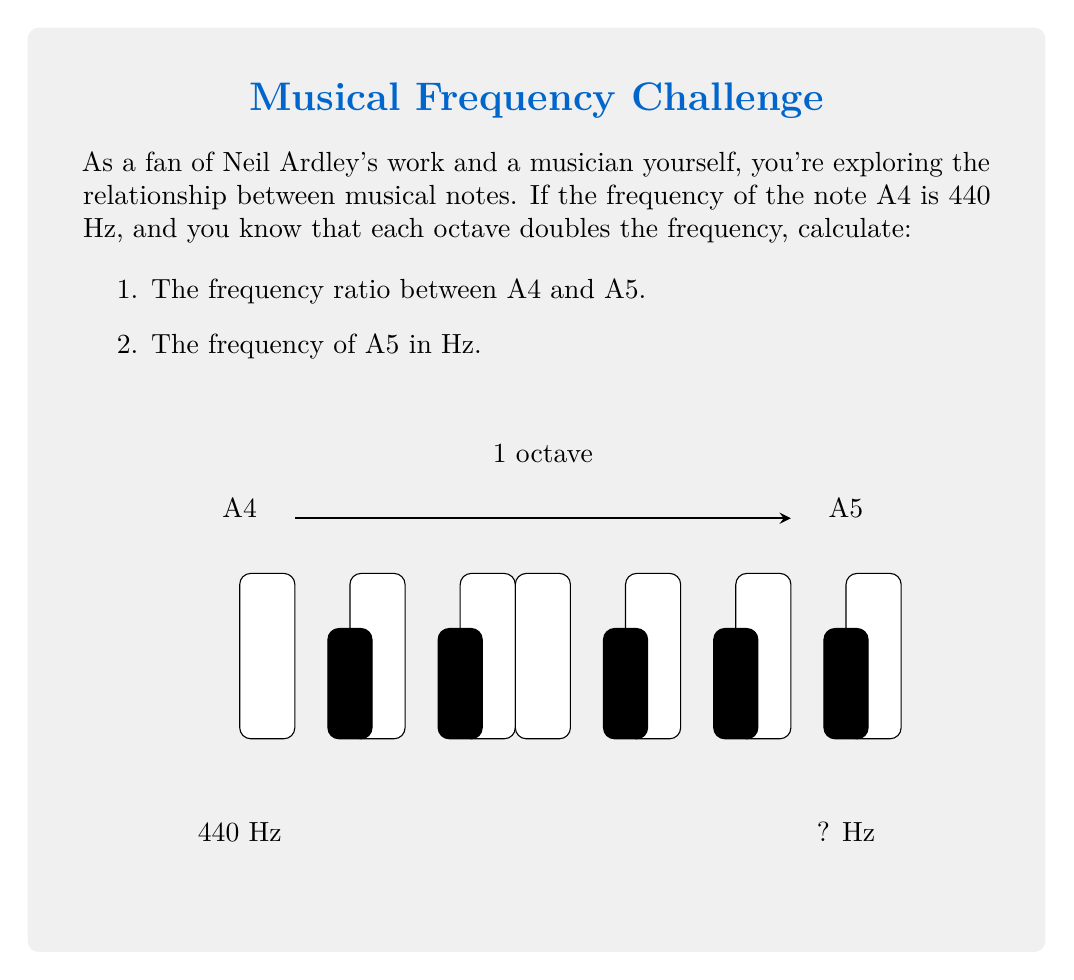Give your solution to this math problem. Let's approach this step-by-step:

1) In music theory, we know that the frequency doubles for each octave. This means that the frequency ratio between two notes an octave apart is 2:1.

2) A4 and A5 are exactly one octave apart. Therefore, the frequency ratio between A4 and A5 is 2:1.

3) To express this as a single number, we divide the higher frequency by the lower frequency:

   $\text{Ratio} = \frac{f_{A5}}{f_{A4}} = \frac{2}{1} = 2$

4) Now, to find the actual frequency of A5:
   
   Given: $f_{A4} = 440 \text{ Hz}$
   
   $f_{A5} = 2 \times f_{A4} = 2 \times 440 \text{ Hz} = 880 \text{ Hz}$

Therefore, the frequency ratio between A4 and A5 is 2, and the frequency of A5 is 880 Hz.
Answer: Ratio: 2, A5 frequency: 880 Hz 